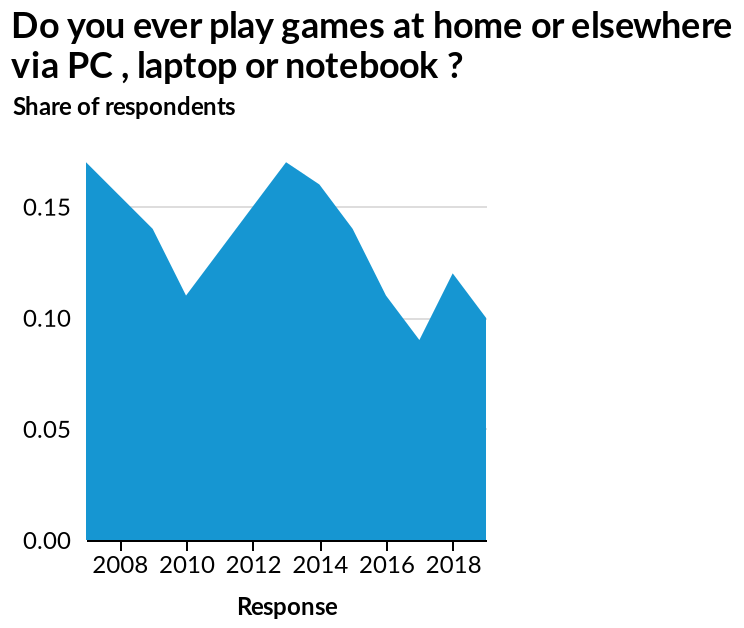<image>
What is the lowest value shown on the x-axis in the area graph? The lowest value shown on the x-axis in the area graph is 2008. 